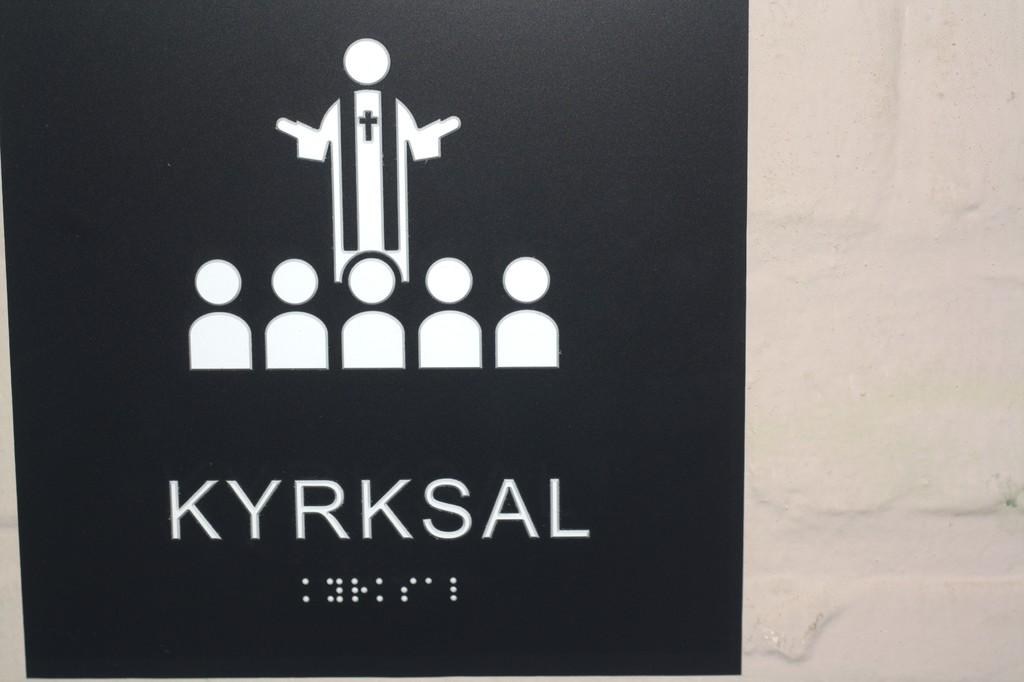Provide a one-sentence caption for the provided image. A sign that has a jesus and children with the word kyrksal on it. 